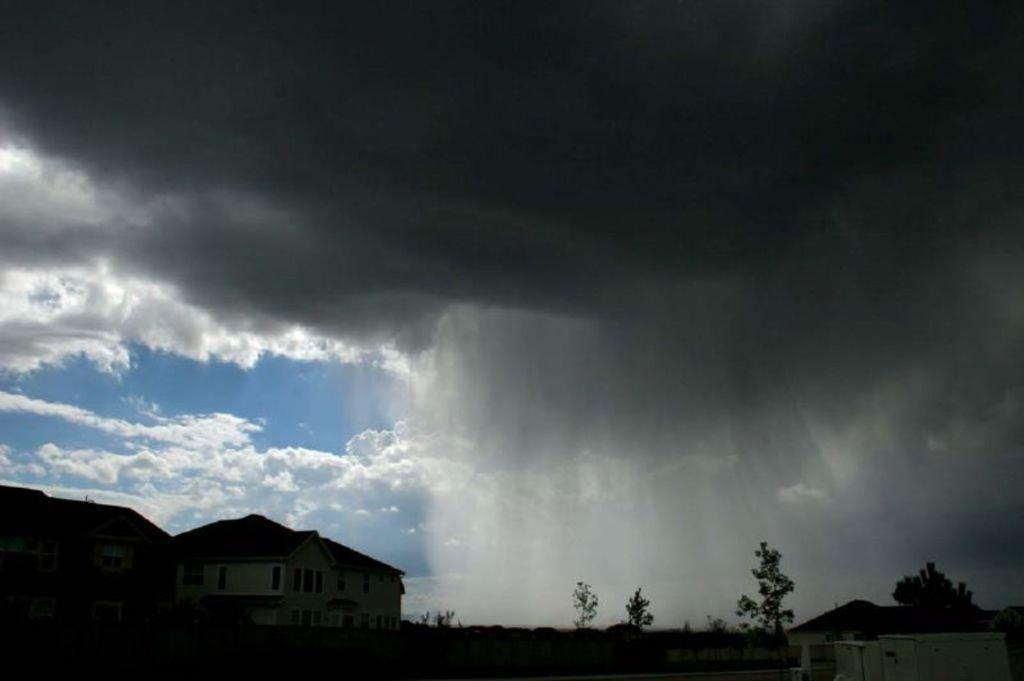Please provide a concise description of this image. In this image, at the bottom there are buildings, trees. In the middle there are clouds, sky. 